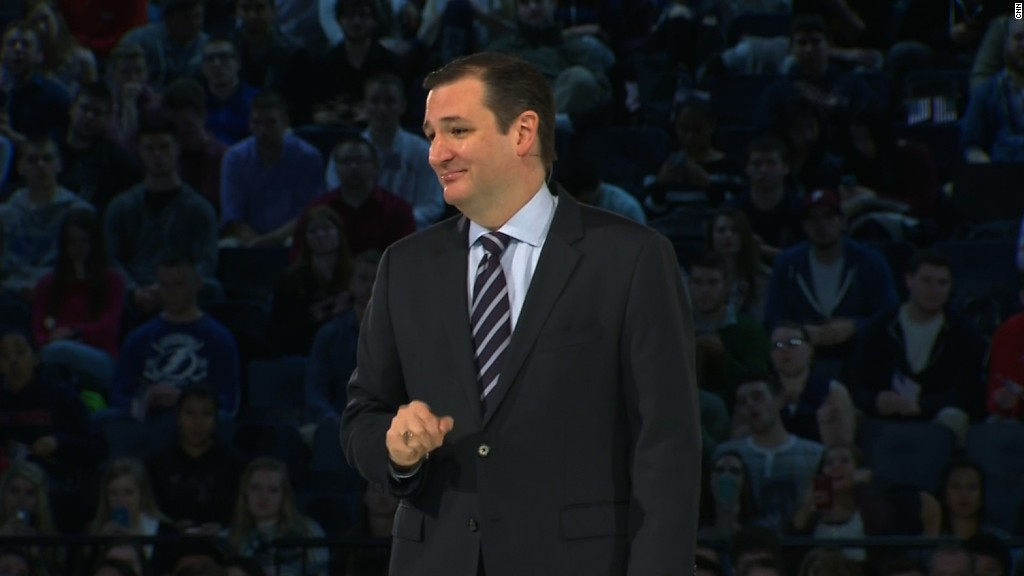Based on the attire and body language of the audience, what type of event could this be, and what is the possible subject matter of the speaker's presentation? Based on the attire and body language of the audience, the event seems to be reasonably informal yet significant enough to draw a large crowd. The casual clothing worn by the audience suggests it could be a university event, such as a guest lecture, a seminar, or a town hall meeting. The speaker's formal attire contrasts with the audience, indicating his role as a professional, possibly a lecturer, expert, or significant public figure. Although the specific subject matter of the presentation is not explicitly indicated by the image, given the academic setting and the speaker's authoritative presence, it is likely related to education, public policy, or another topic warranting formal discussion in an academic or civic context. 